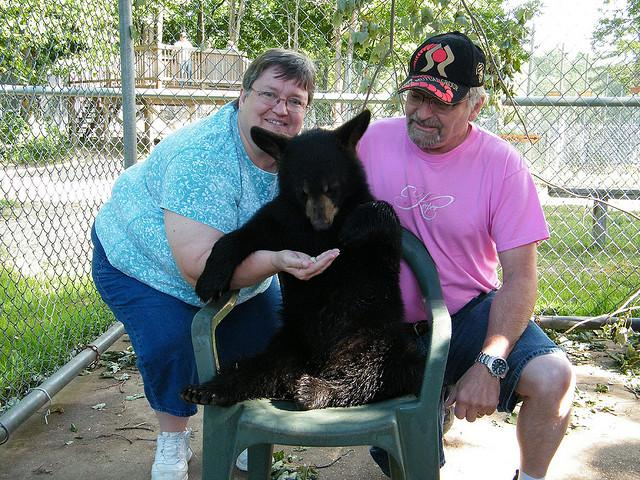What is the woman doing with the bear? feeding 